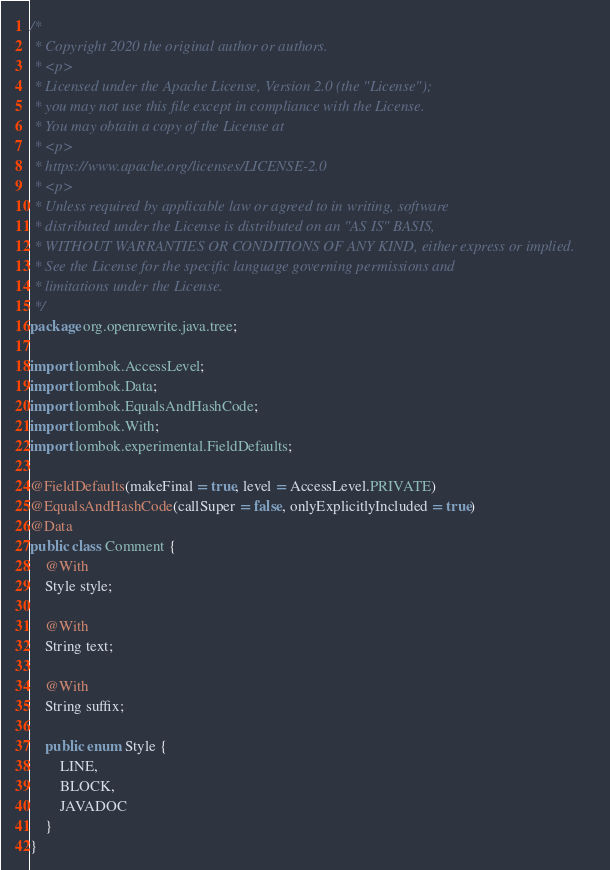Convert code to text. <code><loc_0><loc_0><loc_500><loc_500><_Java_>/*
 * Copyright 2020 the original author or authors.
 * <p>
 * Licensed under the Apache License, Version 2.0 (the "License");
 * you may not use this file except in compliance with the License.
 * You may obtain a copy of the License at
 * <p>
 * https://www.apache.org/licenses/LICENSE-2.0
 * <p>
 * Unless required by applicable law or agreed to in writing, software
 * distributed under the License is distributed on an "AS IS" BASIS,
 * WITHOUT WARRANTIES OR CONDITIONS OF ANY KIND, either express or implied.
 * See the License for the specific language governing permissions and
 * limitations under the License.
 */
package org.openrewrite.java.tree;

import lombok.AccessLevel;
import lombok.Data;
import lombok.EqualsAndHashCode;
import lombok.With;
import lombok.experimental.FieldDefaults;

@FieldDefaults(makeFinal = true, level = AccessLevel.PRIVATE)
@EqualsAndHashCode(callSuper = false, onlyExplicitlyIncluded = true)
@Data
public class Comment {
    @With
    Style style;

    @With
    String text;

    @With
    String suffix;

    public enum Style {
        LINE,
        BLOCK,
        JAVADOC
    }
}
</code> 